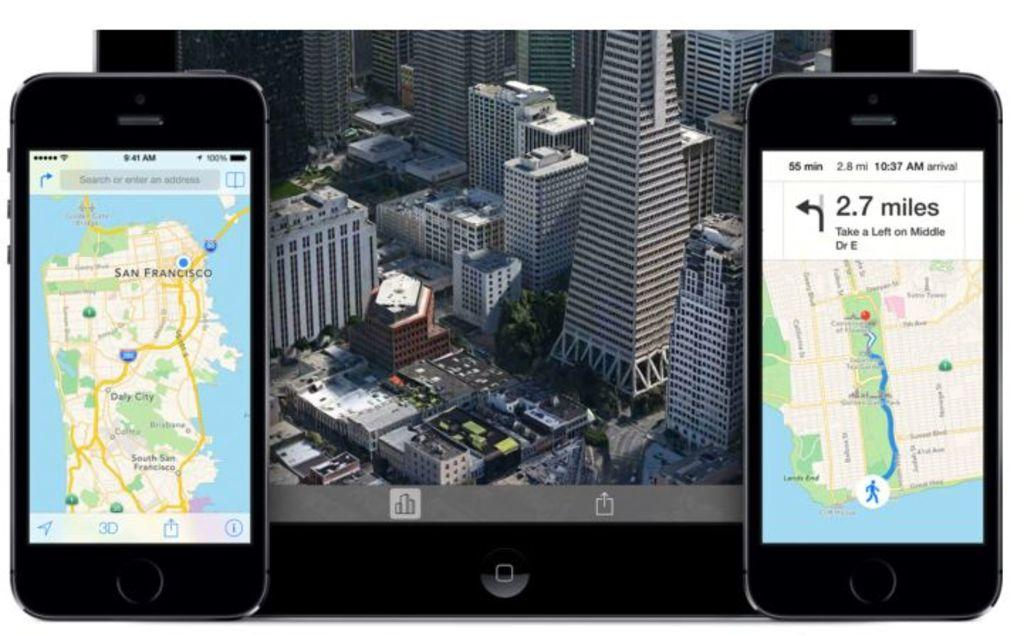<image>
Present a compact description of the photo's key features. Two phones have a gps up and the one on the right shows 2.7 miles until a left turn. 